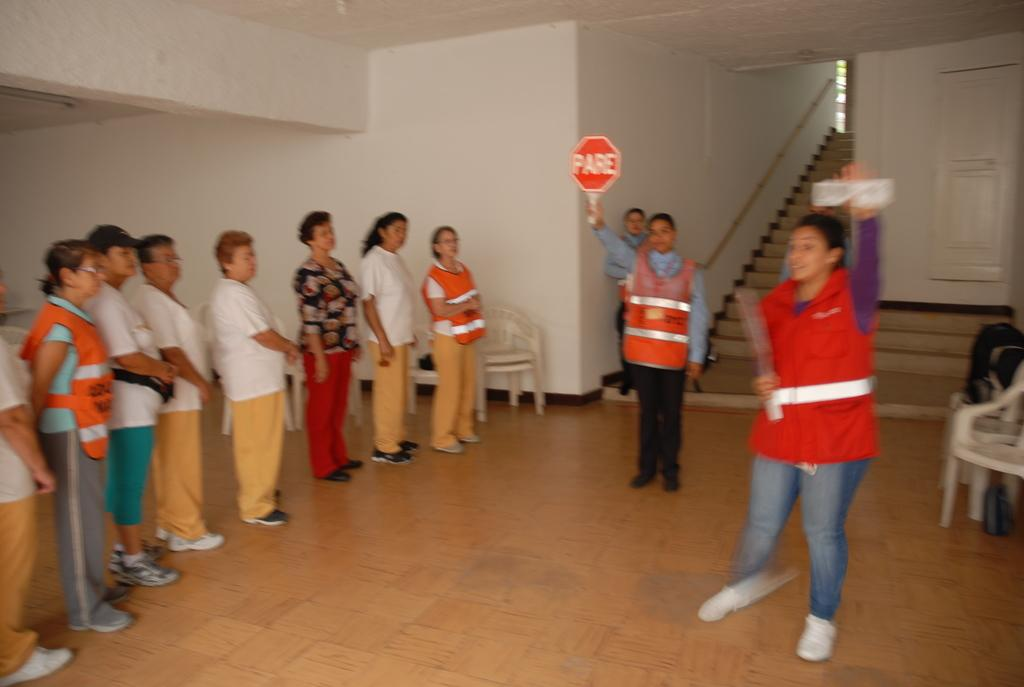<image>
Share a concise interpretation of the image provided. a woman in a reflective vest holding up a sign that says PARE 